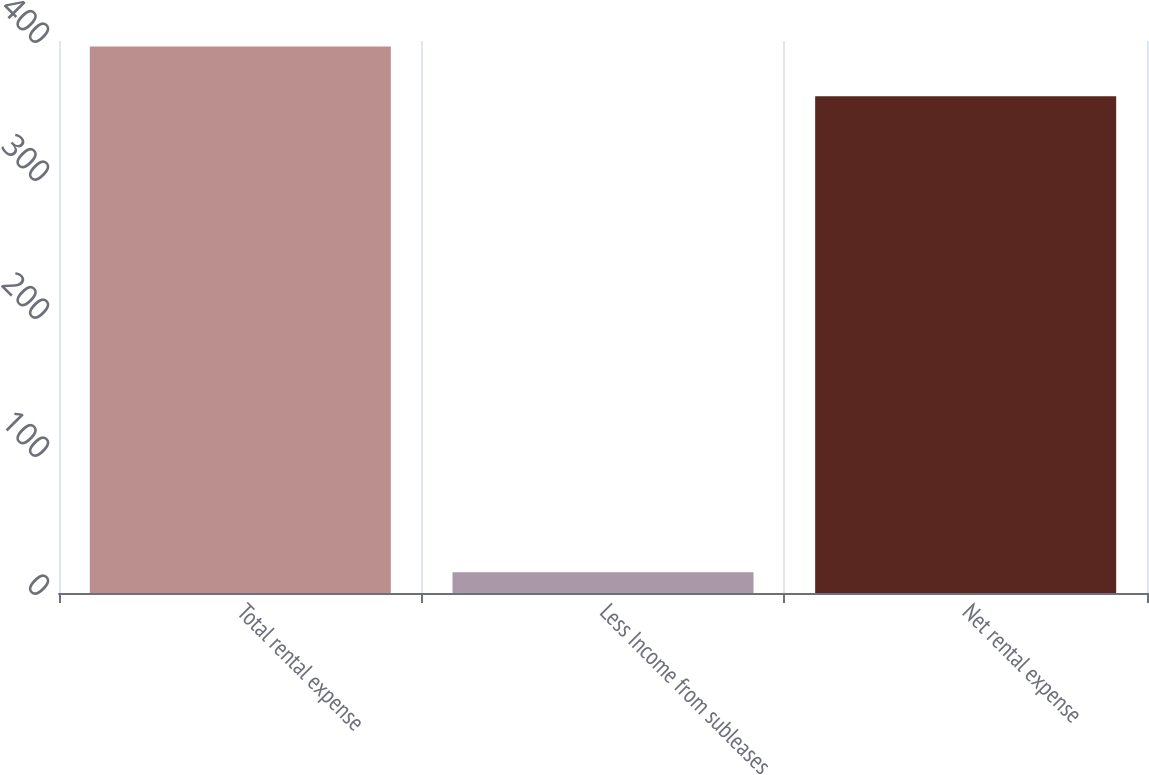Convert chart. <chart><loc_0><loc_0><loc_500><loc_500><bar_chart><fcel>Total rental expense<fcel>Less Income from subleases<fcel>Net rental expense<nl><fcel>396<fcel>15<fcel>360<nl></chart> 